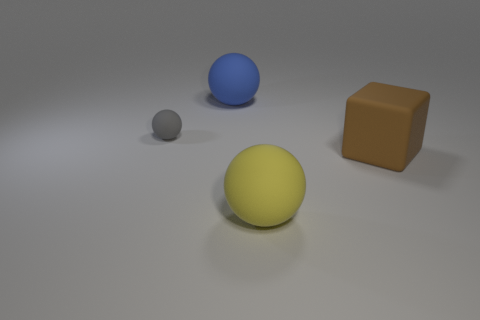Add 1 big objects. How many objects exist? 5 Subtract all balls. How many objects are left? 1 Add 1 small gray rubber things. How many small gray rubber things are left? 2 Add 1 blue cubes. How many blue cubes exist? 1 Subtract 0 green spheres. How many objects are left? 4 Subtract all large red shiny things. Subtract all gray balls. How many objects are left? 3 